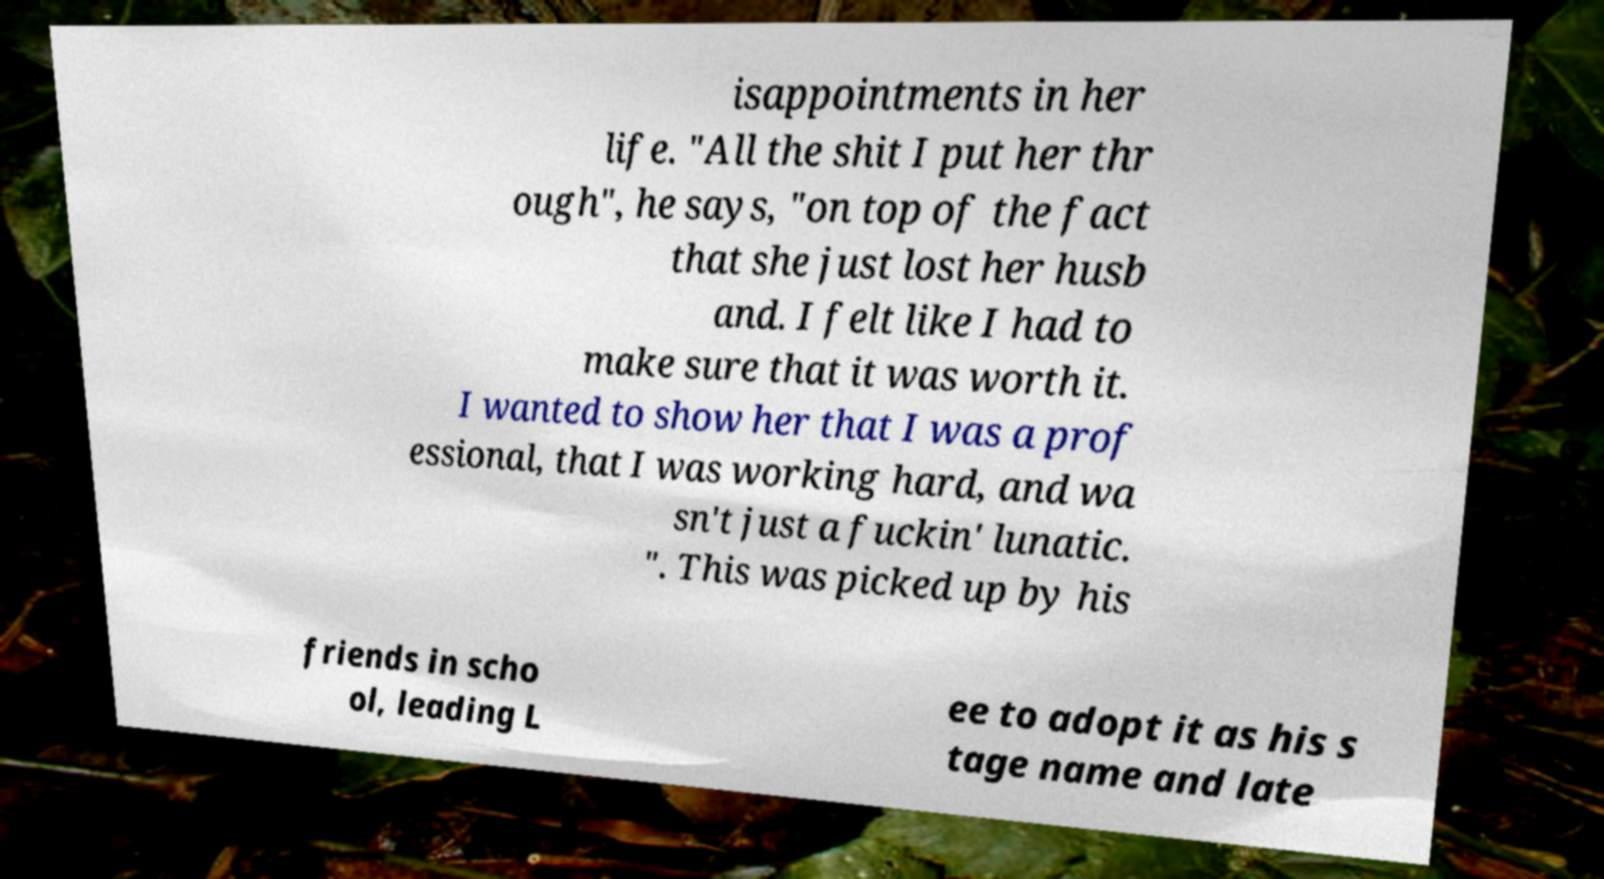Can you read and provide the text displayed in the image?This photo seems to have some interesting text. Can you extract and type it out for me? isappointments in her life. "All the shit I put her thr ough", he says, "on top of the fact that she just lost her husb and. I felt like I had to make sure that it was worth it. I wanted to show her that I was a prof essional, that I was working hard, and wa sn't just a fuckin' lunatic. ". This was picked up by his friends in scho ol, leading L ee to adopt it as his s tage name and late 